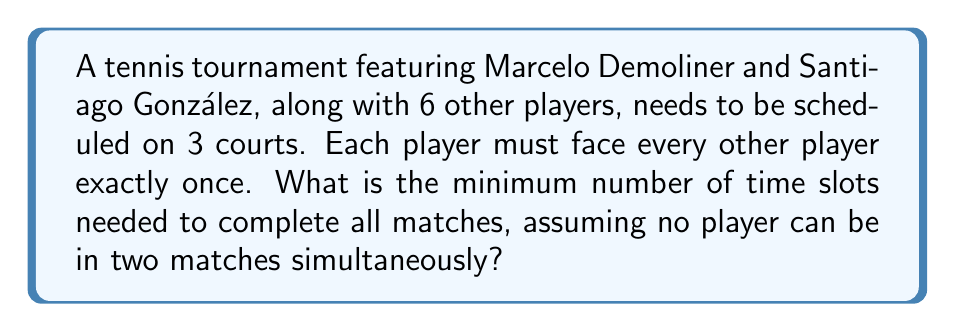Teach me how to tackle this problem. To solve this problem, we can use graph coloring theory. Let's approach this step-by-step:

1) First, we need to determine the total number of matches. With 8 players, each player needs to play 7 matches. The total number of matches is:

   $$ \text{Total matches} = \frac{8 \times 7}{2} = 28 $$

2) We can represent this as a complete graph $K_8$, where each vertex is a player and each edge is a match.

3) The chromatic index of a graph is the minimum number of colors needed to color the edges so that no two adjacent edges have the same color. In our case, each color represents a time slot.

4) For a complete graph $K_n$ where $n$ is even, the chromatic index is $n-1$. In our case, $n=8$, so the chromatic index is 7.

5) This means we need at least 7 time slots to ensure no player is in two matches at once.

6) However, we have 3 courts available. In each time slot, we can schedule 3 matches simultaneously.

7) To find the minimum number of time slots, we divide the total number of matches by the number of courts and round up:

   $$ \text{Minimum time slots} = \left\lceil\frac{28}{3}\right\rceil = \left\lceil 9.33... \right\rceil = 10 $$

Therefore, we need a minimum of 10 time slots to complete all matches on 3 courts.
Answer: 10 time slots 